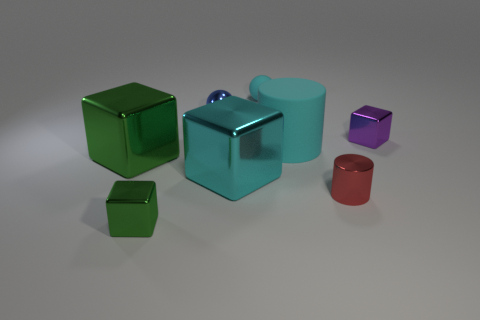There is a cube that is the same color as the rubber sphere; what is it made of?
Ensure brevity in your answer.  Metal. What is the material of the cyan cube that is the same size as the cyan rubber cylinder?
Provide a short and direct response. Metal. There is a cube that is the same color as the big rubber cylinder; what is its size?
Your response must be concise. Large. The small red metallic object has what shape?
Your response must be concise. Cylinder. There is a big thing that is right of the large green shiny object and behind the large cyan block; what color is it?
Provide a short and direct response. Cyan. What is the material of the cyan cylinder?
Offer a terse response. Rubber. What shape is the metallic object behind the small purple shiny cube?
Offer a terse response. Sphere. What is the color of the ball that is the same size as the blue shiny object?
Keep it short and to the point. Cyan. Do the tiny cube that is in front of the small red shiny object and the cyan cylinder have the same material?
Your answer should be compact. No. How big is the shiny object that is right of the tiny cyan matte thing and in front of the tiny purple cube?
Provide a succinct answer. Small. 